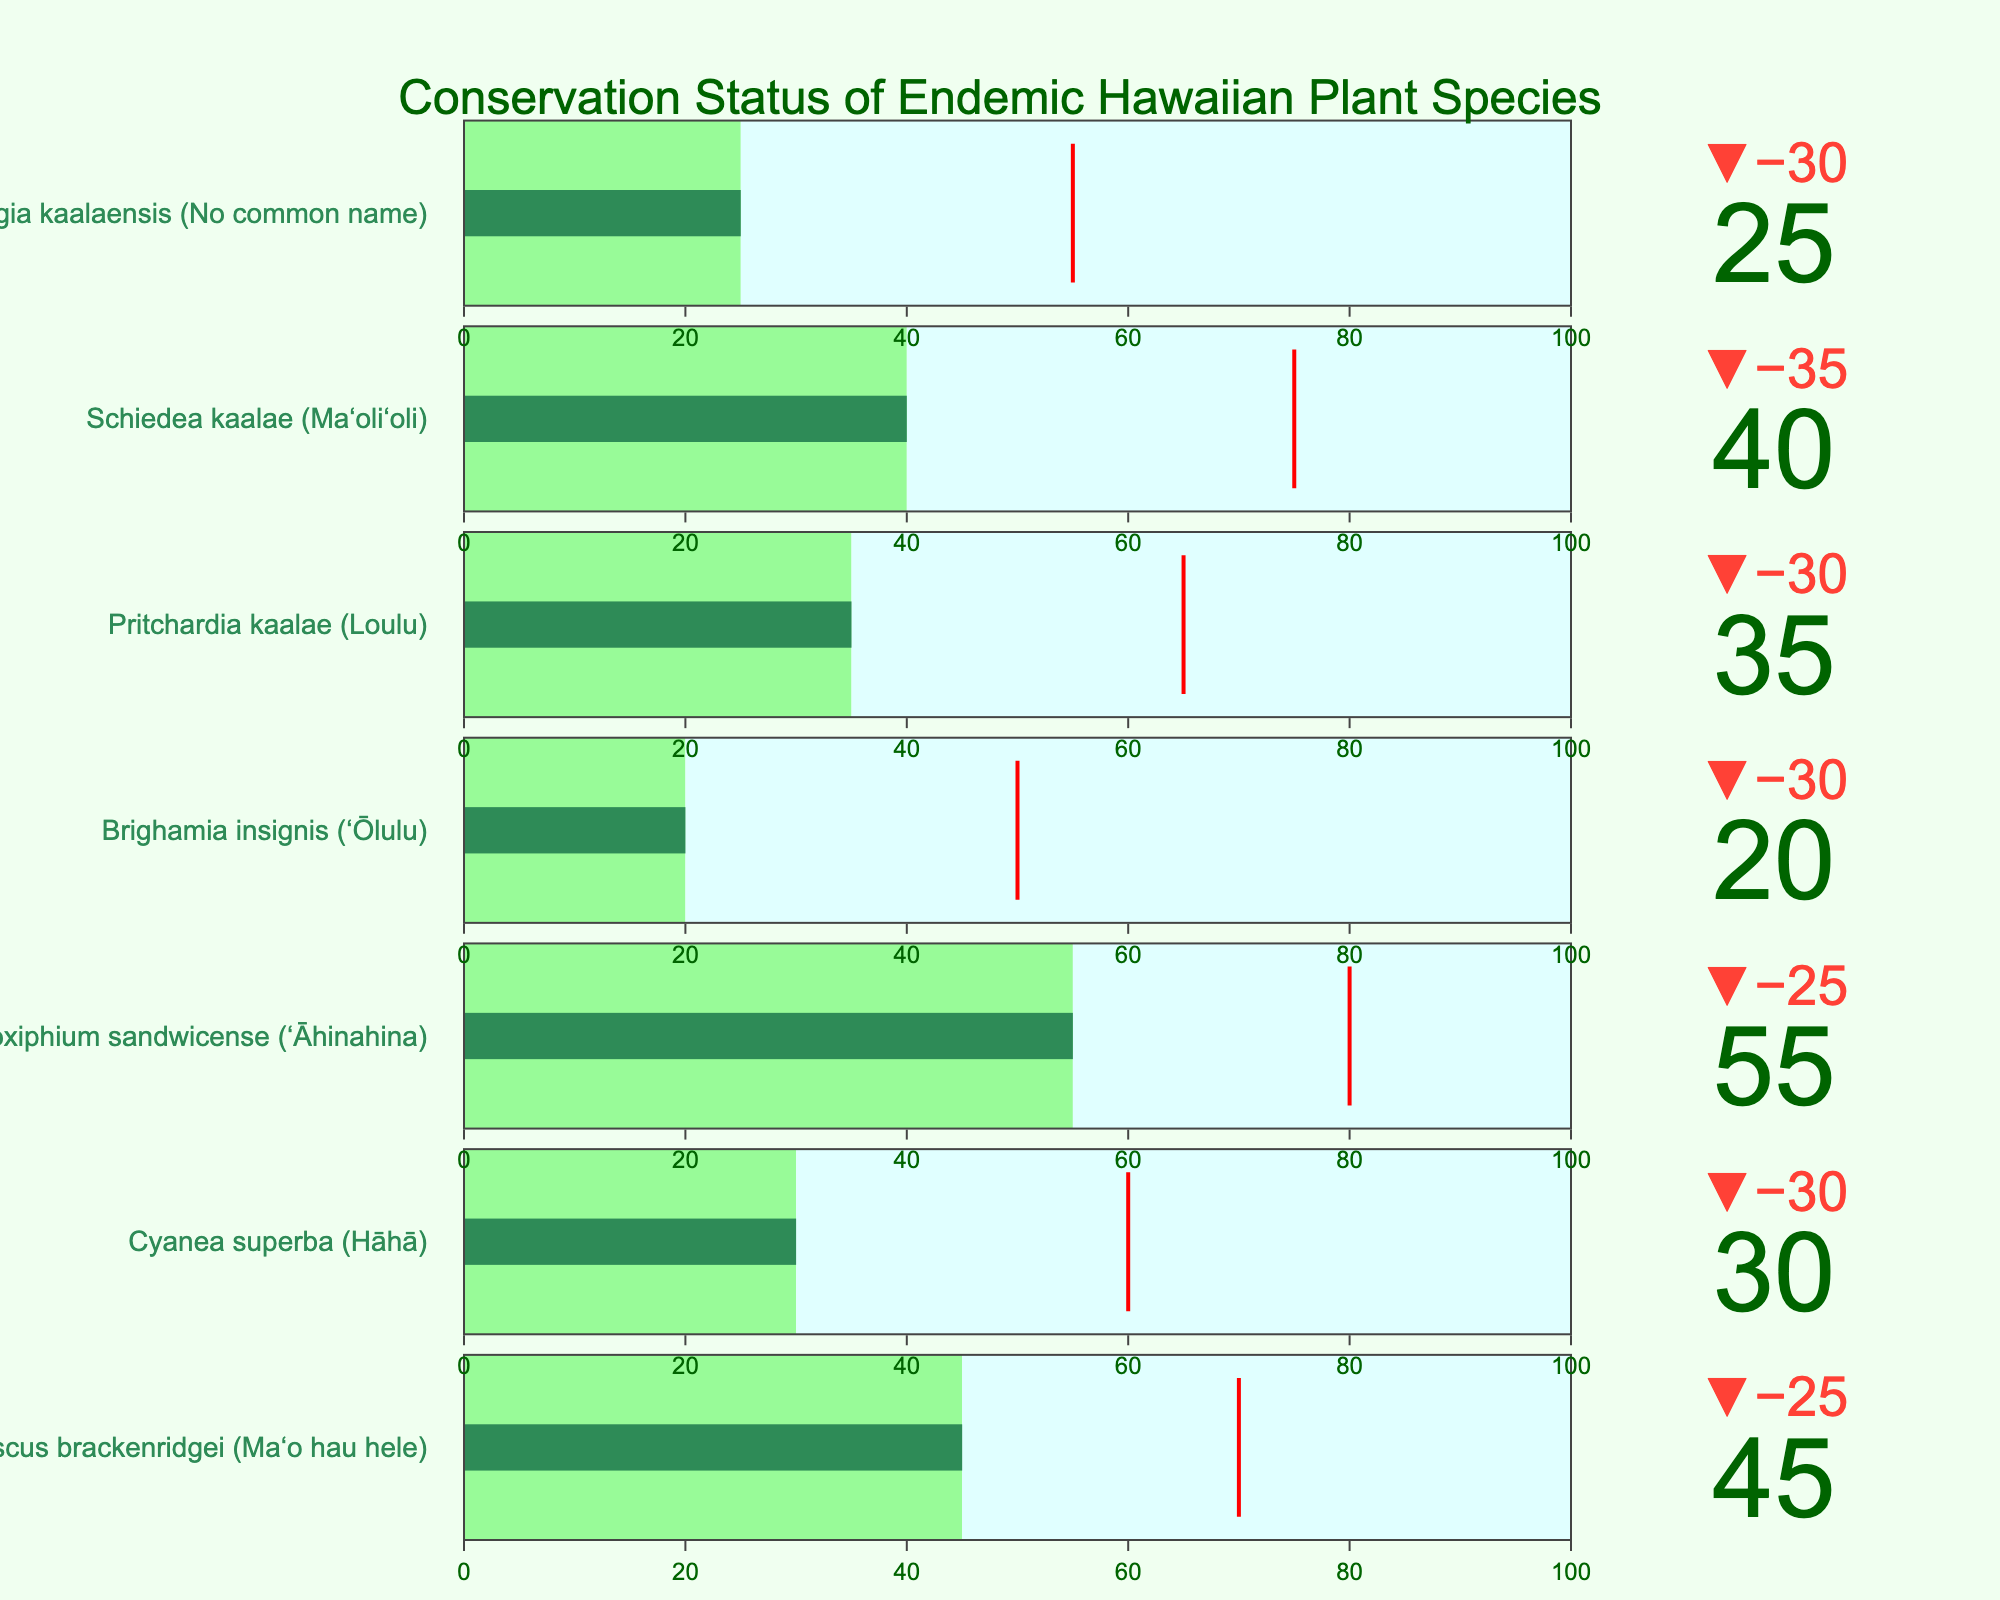What is the current preservation level of Hibiscus brackenridgei (Maʻo hau hele)? The bullet chart for Hibiscus brackenridgei (Maʻo hau hele) shows its current preservation level as 45.
Answer: 45 What is the target preservation level for Cyanea superba (Hāhā)? The target preservation level for Cyanea superba (Hāhā) is indicated by the red threshold line on its bullet chart, which is at 60.
Answer: 60 How much more preservation is needed for Brighamia insignis (ʻŌlulu) to reach its target level? The current preservation level for Brighamia insignis (ʻŌlulu) is 20, and the target level is 50. The difference is 50 - 20 = 30.
Answer: 30 Which plant has the highest current preservation level? By comparing the current preservation levels of all plants in the charts, Argyroxiphium sandwicense (ʻĀhinahina) has the highest level at 55.
Answer: Argyroxiphium sandwicense (ʻĀhinahina) What is the average target preservation level of the seven plant species? Sum the target preservation levels: 70 + 60 + 80 + 50 + 65 + 75 + 55 = 455. Divide this sum by the number of species: 455 / 7 ≈ 65.
Answer: 65 Which species have current preservation levels that are less than half of their maximum preservation? Maximum preservation is 100 for all; half is 50. Species with current preservation levels below 50 are Cyanea superba (30), Brighamia insignis (20), Pritchardia kaalae (35), and Phyllostegia kaalaensis (25).
Answer: Cyanea superba, Brighamia insignis, Pritchardia kaalae, Phyllostegia kaalaensis How does the preservation of Phyllostegia kaalaensis compare to its target level? Phyllostegia kaalaensis has a current preservation level of 25, while its target level is 55, meaning it's 30 units below target.
Answer: 30 units below Which plant is the farthest from achieving its preservation target in absolute terms? By calculating the difference between current and target levels for each plant, Brighamia insignis (ʻŌlulu) has the largest gap: 50 - 20 = 30.
Answer: Brighamia insignis (ʻŌlulu) What percentage of the target level has Schiedea kaalae (Maʻoliʻoli) achieved? Schiedea kaalae's current preservation is 40 and its target is 75. Calculate the percentage: (40/75) * 100 ≈ 53.3%.
Answer: 53.3% Out of the listed plants, which one exceeds half of its target preservation level but hasn't reached it yet? Plants exceeding 50% but not 100% of their target include Argyroxiphium sandwicense (55 of 80), Hibiscus brackenridgei (45 of 70), Schiedea kaalae (40 of 75), and Pritchardia kaalae (35 of 65).
Answer: Argyroxiphium sandwicense, Hibiscus brackenridgei, Schiedea kaalae, Pritchardia kaalae 